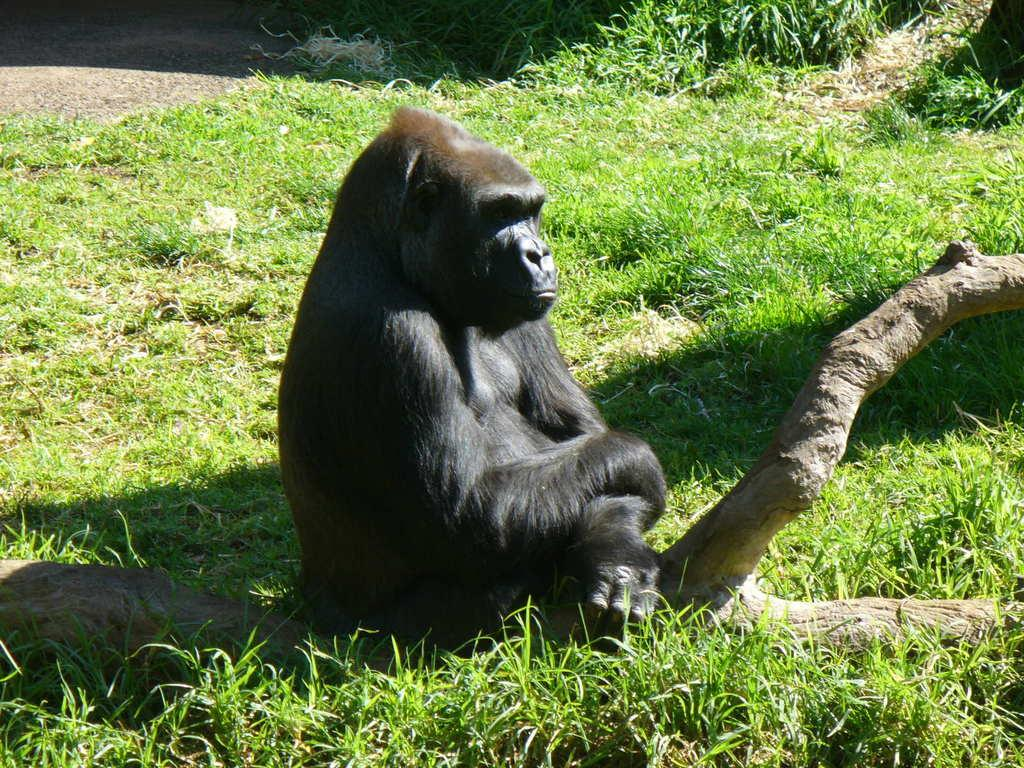What type of animal is in the image? There is a chimpanzee in the image. Where is the chimpanzee located? The chimpanzee is on a branch. What can be seen in the background of the image? The background of the image includes ground covered with grass. What type of lamp is hanging from the branch in the image? There is no lamp present in the image; it features a chimpanzee on a branch. Is the chimpanzee stuck in quicksand in the image? No, the chimpanzee is not in quicksand; it is on a branch. 